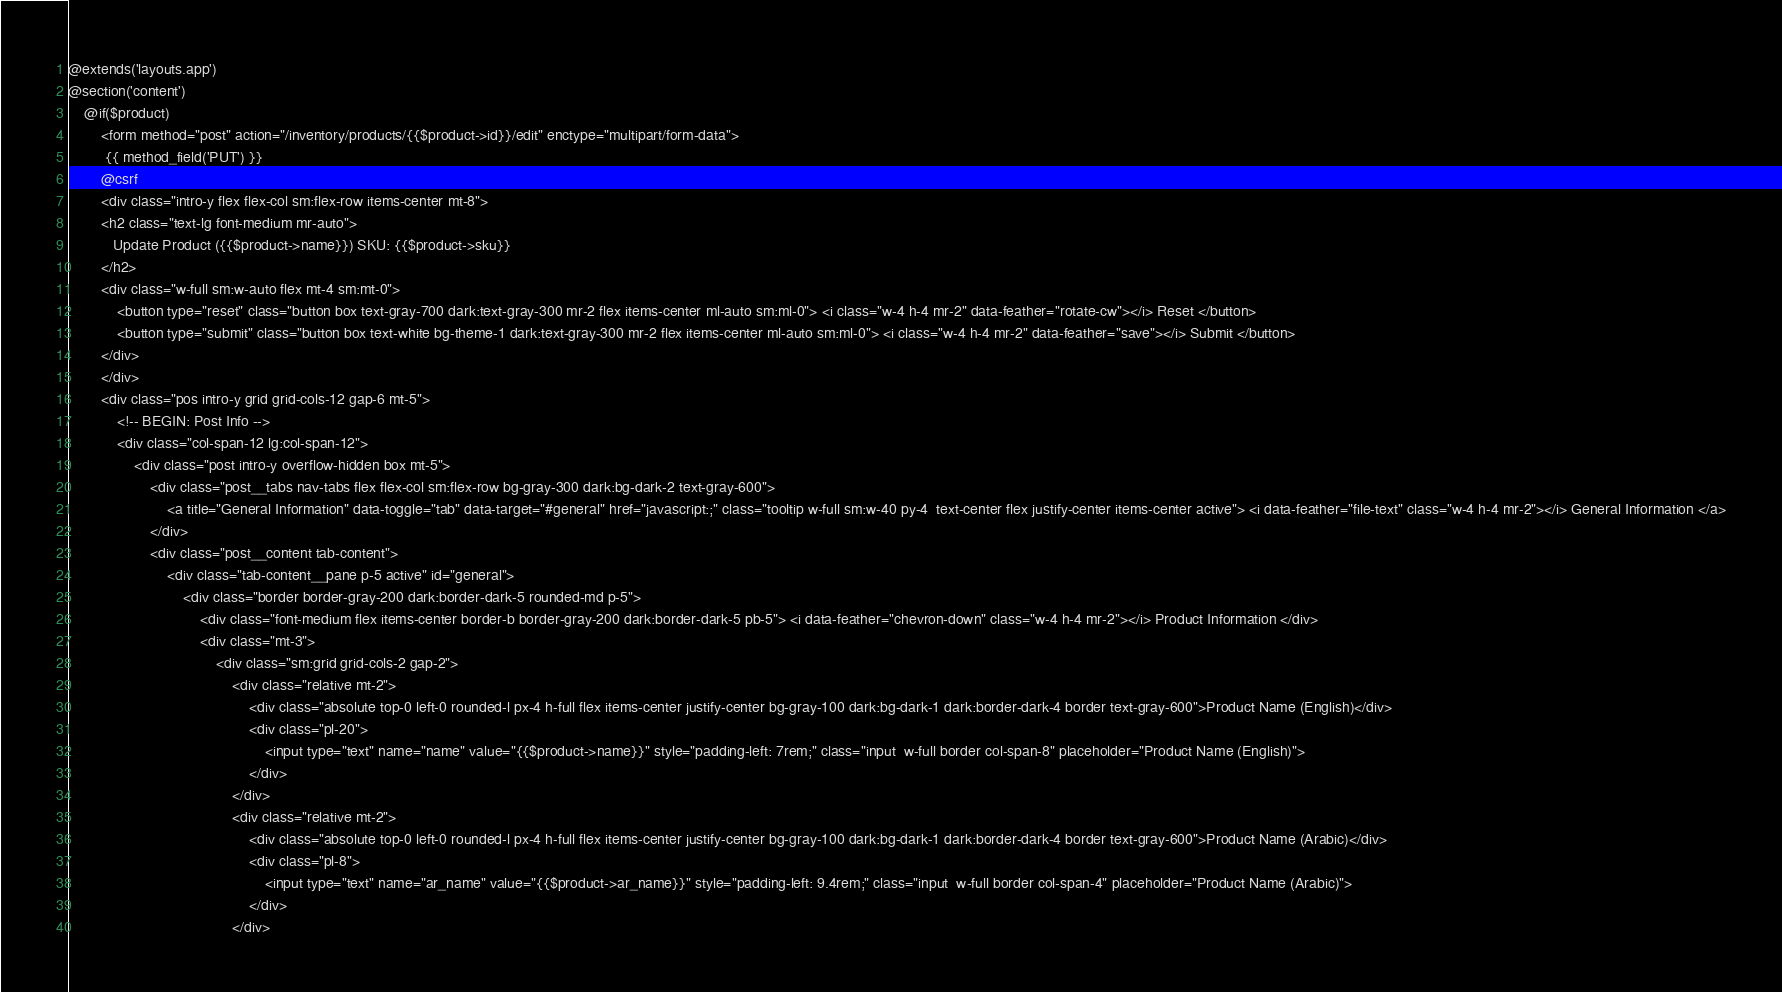<code> <loc_0><loc_0><loc_500><loc_500><_PHP_>@extends('layouts.app')
@section('content')
    @if($product)
        <form method="post" action="/inventory/products/{{$product->id}}/edit" enctype="multipart/form-data">
         {{ method_field('PUT') }}
        @csrf
        <div class="intro-y flex flex-col sm:flex-row items-center mt-8">
        <h2 class="text-lg font-medium mr-auto">
           Update Product ({{$product->name}}) SKU: {{$product->sku}}
        </h2>
        <div class="w-full sm:w-auto flex mt-4 sm:mt-0">
            <button type="reset" class="button box text-gray-700 dark:text-gray-300 mr-2 flex items-center ml-auto sm:ml-0"> <i class="w-4 h-4 mr-2" data-feather="rotate-cw"></i> Reset </button>
            <button type="submit" class="button box text-white bg-theme-1 dark:text-gray-300 mr-2 flex items-center ml-auto sm:ml-0"> <i class="w-4 h-4 mr-2" data-feather="save"></i> Submit </button>
        </div>
        </div>
        <div class="pos intro-y grid grid-cols-12 gap-6 mt-5">
            <!-- BEGIN: Post Info -->
            <div class="col-span-12 lg:col-span-12">
                <div class="post intro-y overflow-hidden box mt-5">
                    <div class="post__tabs nav-tabs flex flex-col sm:flex-row bg-gray-300 dark:bg-dark-2 text-gray-600">
                        <a title="General Information" data-toggle="tab" data-target="#general" href="javascript:;" class="tooltip w-full sm:w-40 py-4  text-center flex justify-center items-center active"> <i data-feather="file-text" class="w-4 h-4 mr-2"></i> General Information </a>
                    </div>
                    <div class="post__content tab-content">
                        <div class="tab-content__pane p-5 active" id="general">
                            <div class="border border-gray-200 dark:border-dark-5 rounded-md p-5">
                                <div class="font-medium flex items-center border-b border-gray-200 dark:border-dark-5 pb-5"> <i data-feather="chevron-down" class="w-4 h-4 mr-2"></i> Product Information </div>
                                <div class="mt-3">
                                    <div class="sm:grid grid-cols-2 gap-2">
                                        <div class="relative mt-2">
                                            <div class="absolute top-0 left-0 rounded-l px-4 h-full flex items-center justify-center bg-gray-100 dark:bg-dark-1 dark:border-dark-4 border text-gray-600">Product Name (English)</div>
                                            <div class="pl-20">
                                                <input type="text" name="name" value="{{$product->name}}" style="padding-left: 7rem;" class="input  w-full border col-span-8" placeholder="Product Name (English)">
                                            </div>
                                        </div>
                                        <div class="relative mt-2">
                                            <div class="absolute top-0 left-0 rounded-l px-4 h-full flex items-center justify-center bg-gray-100 dark:bg-dark-1 dark:border-dark-4 border text-gray-600">Product Name (Arabic)</div>
                                            <div class="pl-8">
                                                <input type="text" name="ar_name" value="{{$product->ar_name}}" style="padding-left: 9.4rem;" class="input  w-full border col-span-4" placeholder="Product Name (Arabic)">
                                            </div>
                                        </div></code> 